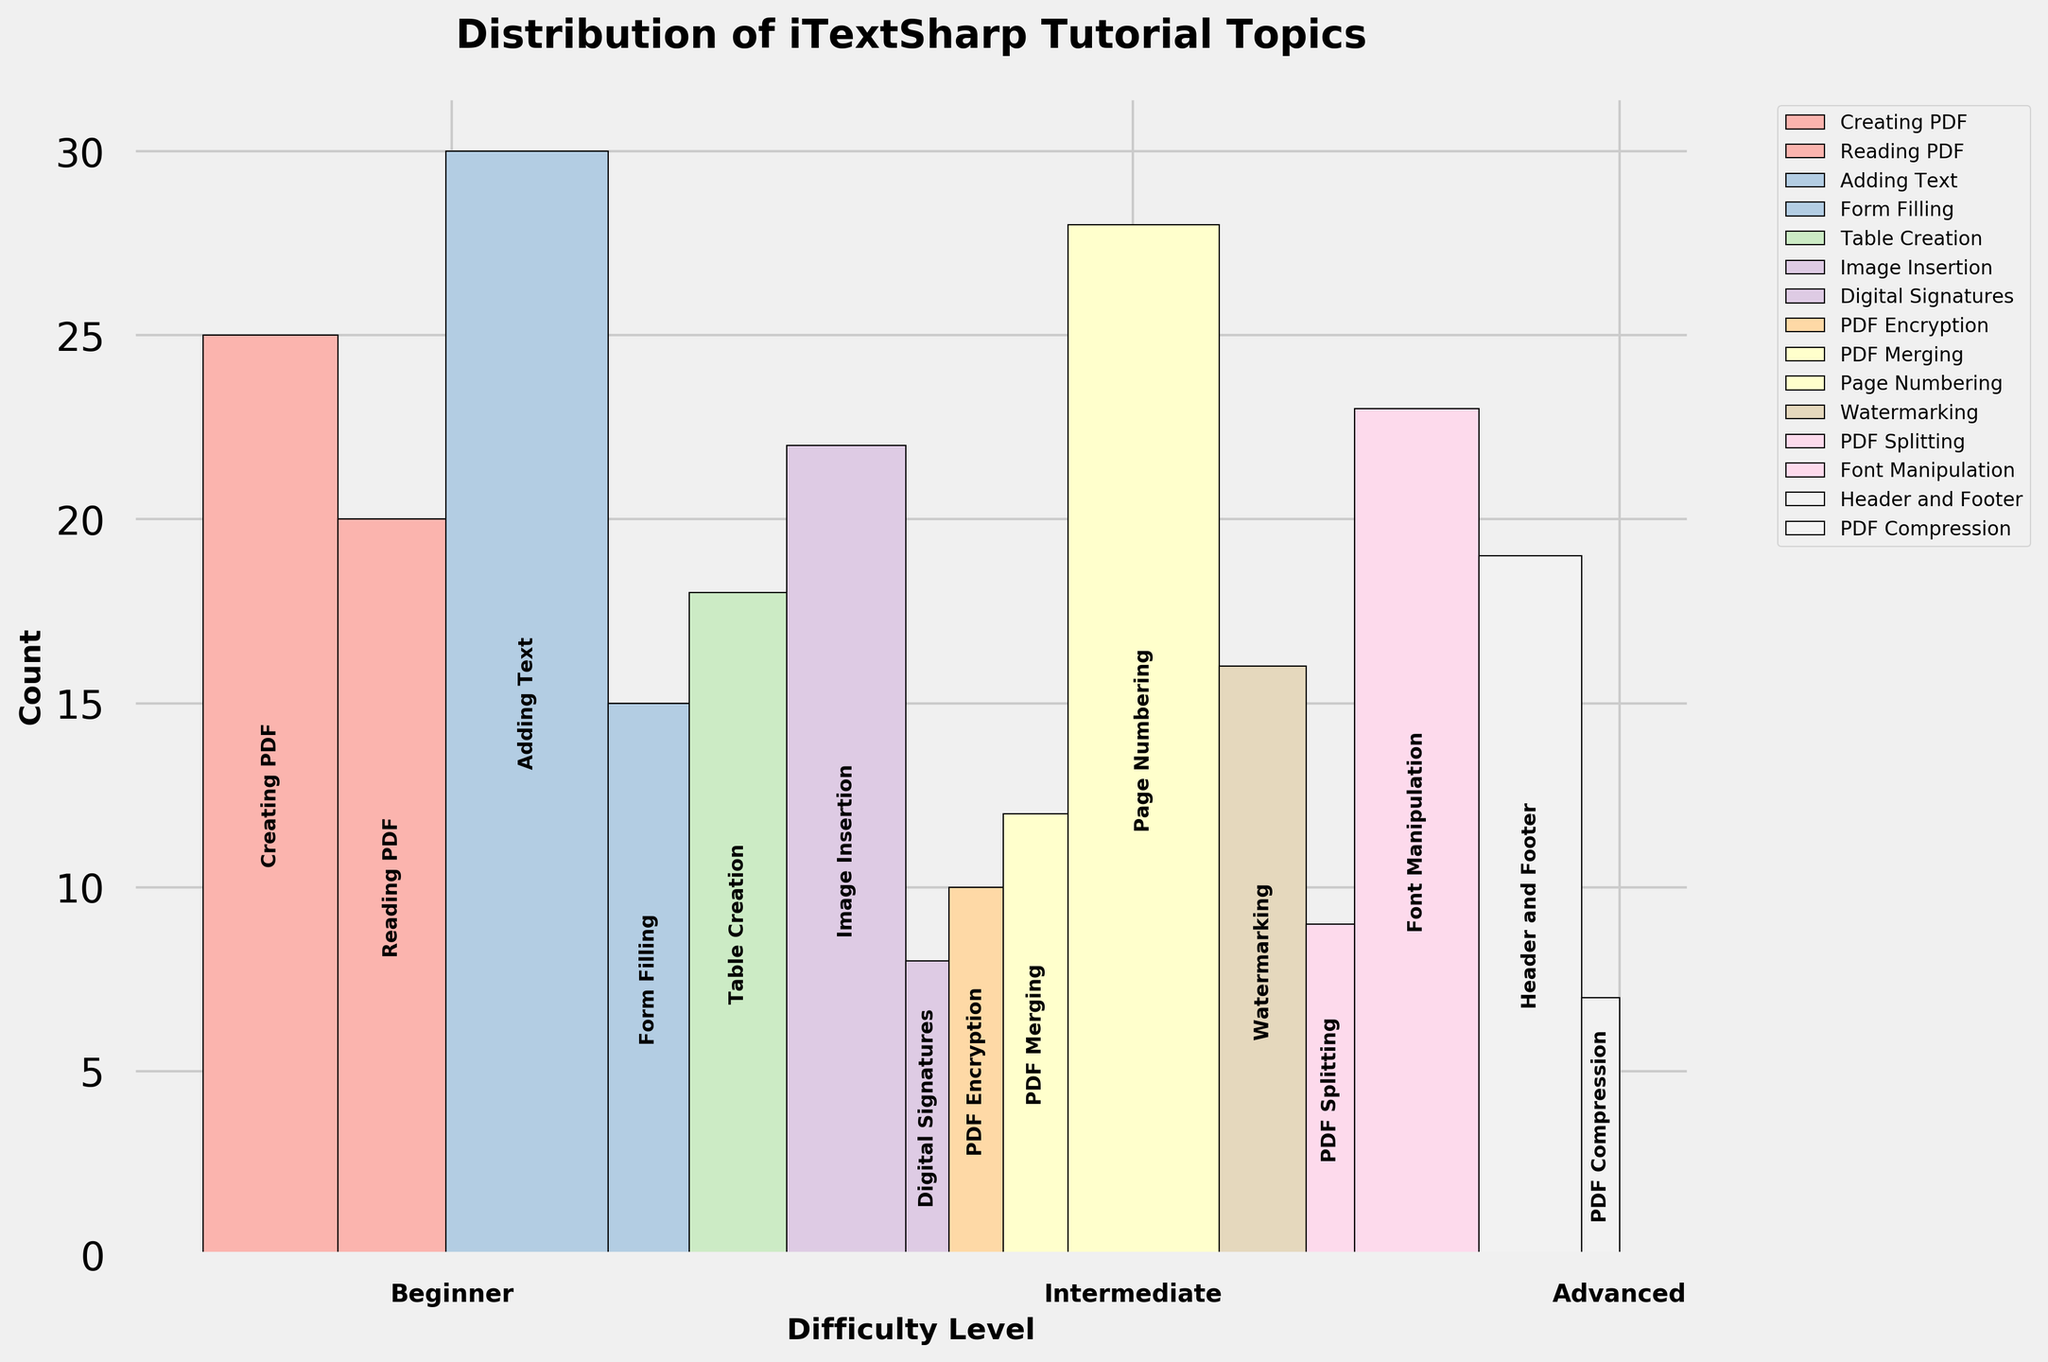Which difficulty level has the highest total count of tutorials? By examining the sums of the counts for each difficulty level, Beginner has the highest number with more tutorial counts for tasks like Creating PDF, Reading PDF, Adding Text, Page Numbering, and Font Manipulation.
Answer: Beginner How many total tutorials are there for "Beginner" tasks? Summing the counts of all Beginner tasks: Creating PDF (25) + Reading PDF (20) + Adding Text (30) + Page Numbering (28) + Font Manipulation (23).
Answer: 126 Which task has the highest count under the "Beginner" difficulty level? Among the Beginner tasks, we need to find the highest count. Adding Text has the highest with 30 counts.
Answer: Adding Text What's the combined count of tutorials for "Intermediate" tasks related to text or watermark modification? Adding up counts for tasks like Form Filling (15) + Table Creation (18) + Header and Footer (19) + Watermarking (16).
Answer: 68 Which difficulty level has the fewest tutorial counts for all tasks combined? By summing the counts for each difficulty level, Advanced has the fewest tutorial counts.
Answer: Advanced Is there any task which appears in all difficulty levels? Checking if any task is common in Beginner, Intermediate, and Advanced tasks. No task is common across all levels.
Answer: No How does the tutorial count for "Adding Text" compare between "Beginner" and "Intermediate"? Comparing the count of "Adding Text" between Beginner and Intermediate; Beginner has 30 counts and Intermediate does not have this task.
Answer: Beginner Calculate the total count for "PDF Encryption" and "Digital Signatures" under the "Advanced" difficulty. Adding the counts of “PDF Encryption” (10) and “Digital Signatures” (8).
Answer: 18 Which difficulty level has the largest diversity in terms of task types? By noticing the number of different tasks at each level, Beginner and Intermediate both cover more ground with 5 different tasks each compared to 6 in Advanced.
Answer: Beginner, Intermediate What's the difference in count between "Creating PDF" and "Reading PDF" for "Beginner" difficulty? Subtracting the count of "Reading PDF" (20) from "Creating PDF" (25) within the Beginner difficulty.
Answer: 5 